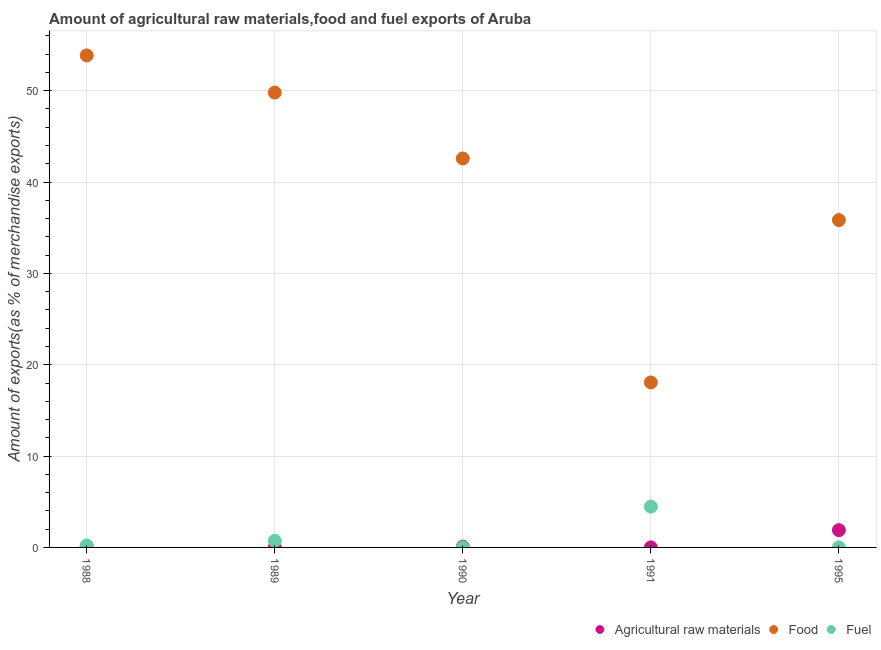What is the percentage of fuel exports in 1989?
Make the answer very short. 0.73. Across all years, what is the maximum percentage of food exports?
Your answer should be compact. 53.86. Across all years, what is the minimum percentage of food exports?
Your answer should be compact. 18.06. In which year was the percentage of raw materials exports maximum?
Offer a terse response. 1995. What is the total percentage of raw materials exports in the graph?
Provide a short and direct response. 2.08. What is the difference between the percentage of fuel exports in 1988 and that in 1989?
Keep it short and to the point. -0.51. What is the difference between the percentage of food exports in 1995 and the percentage of fuel exports in 1991?
Offer a terse response. 31.37. What is the average percentage of raw materials exports per year?
Offer a terse response. 0.42. In the year 1990, what is the difference between the percentage of raw materials exports and percentage of food exports?
Provide a short and direct response. -42.5. In how many years, is the percentage of food exports greater than 44 %?
Ensure brevity in your answer.  2. What is the ratio of the percentage of raw materials exports in 1989 to that in 1991?
Offer a terse response. 2.86. Is the difference between the percentage of fuel exports in 1989 and 1990 greater than the difference between the percentage of raw materials exports in 1989 and 1990?
Give a very brief answer. Yes. What is the difference between the highest and the second highest percentage of fuel exports?
Offer a terse response. 3.74. What is the difference between the highest and the lowest percentage of raw materials exports?
Keep it short and to the point. 1.89. Is the percentage of food exports strictly greater than the percentage of raw materials exports over the years?
Provide a succinct answer. Yes. Is the percentage of fuel exports strictly less than the percentage of raw materials exports over the years?
Keep it short and to the point. No. How many dotlines are there?
Your response must be concise. 3. Does the graph contain any zero values?
Keep it short and to the point. No. Does the graph contain grids?
Keep it short and to the point. Yes. Where does the legend appear in the graph?
Give a very brief answer. Bottom right. What is the title of the graph?
Your response must be concise. Amount of agricultural raw materials,food and fuel exports of Aruba. What is the label or title of the X-axis?
Make the answer very short. Year. What is the label or title of the Y-axis?
Offer a terse response. Amount of exports(as % of merchandise exports). What is the Amount of exports(as % of merchandise exports) in Agricultural raw materials in 1988?
Give a very brief answer. 0.09. What is the Amount of exports(as % of merchandise exports) of Food in 1988?
Your answer should be very brief. 53.86. What is the Amount of exports(as % of merchandise exports) of Fuel in 1988?
Ensure brevity in your answer.  0.21. What is the Amount of exports(as % of merchandise exports) in Agricultural raw materials in 1989?
Keep it short and to the point. 0.01. What is the Amount of exports(as % of merchandise exports) in Food in 1989?
Provide a succinct answer. 49.8. What is the Amount of exports(as % of merchandise exports) of Fuel in 1989?
Your answer should be very brief. 0.73. What is the Amount of exports(as % of merchandise exports) in Agricultural raw materials in 1990?
Give a very brief answer. 0.08. What is the Amount of exports(as % of merchandise exports) in Food in 1990?
Your response must be concise. 42.58. What is the Amount of exports(as % of merchandise exports) of Fuel in 1990?
Ensure brevity in your answer.  0. What is the Amount of exports(as % of merchandise exports) in Agricultural raw materials in 1991?
Ensure brevity in your answer.  0. What is the Amount of exports(as % of merchandise exports) in Food in 1991?
Your answer should be compact. 18.06. What is the Amount of exports(as % of merchandise exports) in Fuel in 1991?
Give a very brief answer. 4.46. What is the Amount of exports(as % of merchandise exports) in Agricultural raw materials in 1995?
Offer a terse response. 1.89. What is the Amount of exports(as % of merchandise exports) of Food in 1995?
Your response must be concise. 35.83. What is the Amount of exports(as % of merchandise exports) of Fuel in 1995?
Keep it short and to the point. 0.01. Across all years, what is the maximum Amount of exports(as % of merchandise exports) in Agricultural raw materials?
Keep it short and to the point. 1.89. Across all years, what is the maximum Amount of exports(as % of merchandise exports) of Food?
Your response must be concise. 53.86. Across all years, what is the maximum Amount of exports(as % of merchandise exports) in Fuel?
Keep it short and to the point. 4.46. Across all years, what is the minimum Amount of exports(as % of merchandise exports) of Agricultural raw materials?
Ensure brevity in your answer.  0. Across all years, what is the minimum Amount of exports(as % of merchandise exports) in Food?
Give a very brief answer. 18.06. Across all years, what is the minimum Amount of exports(as % of merchandise exports) in Fuel?
Your response must be concise. 0. What is the total Amount of exports(as % of merchandise exports) of Agricultural raw materials in the graph?
Give a very brief answer. 2.08. What is the total Amount of exports(as % of merchandise exports) in Food in the graph?
Give a very brief answer. 200.14. What is the total Amount of exports(as % of merchandise exports) of Fuel in the graph?
Offer a very short reply. 5.42. What is the difference between the Amount of exports(as % of merchandise exports) in Agricultural raw materials in 1988 and that in 1989?
Make the answer very short. 0.08. What is the difference between the Amount of exports(as % of merchandise exports) in Food in 1988 and that in 1989?
Make the answer very short. 4.07. What is the difference between the Amount of exports(as % of merchandise exports) of Fuel in 1988 and that in 1989?
Your answer should be very brief. -0.51. What is the difference between the Amount of exports(as % of merchandise exports) in Agricultural raw materials in 1988 and that in 1990?
Give a very brief answer. 0.01. What is the difference between the Amount of exports(as % of merchandise exports) in Food in 1988 and that in 1990?
Make the answer very short. 11.29. What is the difference between the Amount of exports(as % of merchandise exports) in Fuel in 1988 and that in 1990?
Your response must be concise. 0.21. What is the difference between the Amount of exports(as % of merchandise exports) of Agricultural raw materials in 1988 and that in 1991?
Give a very brief answer. 0.09. What is the difference between the Amount of exports(as % of merchandise exports) in Food in 1988 and that in 1991?
Your response must be concise. 35.8. What is the difference between the Amount of exports(as % of merchandise exports) in Fuel in 1988 and that in 1991?
Offer a very short reply. -4.25. What is the difference between the Amount of exports(as % of merchandise exports) in Agricultural raw materials in 1988 and that in 1995?
Offer a very short reply. -1.8. What is the difference between the Amount of exports(as % of merchandise exports) of Food in 1988 and that in 1995?
Keep it short and to the point. 18.03. What is the difference between the Amount of exports(as % of merchandise exports) of Fuel in 1988 and that in 1995?
Provide a short and direct response. 0.2. What is the difference between the Amount of exports(as % of merchandise exports) in Agricultural raw materials in 1989 and that in 1990?
Your answer should be compact. -0.07. What is the difference between the Amount of exports(as % of merchandise exports) of Food in 1989 and that in 1990?
Give a very brief answer. 7.22. What is the difference between the Amount of exports(as % of merchandise exports) in Fuel in 1989 and that in 1990?
Offer a very short reply. 0.72. What is the difference between the Amount of exports(as % of merchandise exports) in Agricultural raw materials in 1989 and that in 1991?
Your answer should be very brief. 0.01. What is the difference between the Amount of exports(as % of merchandise exports) in Food in 1989 and that in 1991?
Provide a short and direct response. 31.73. What is the difference between the Amount of exports(as % of merchandise exports) in Fuel in 1989 and that in 1991?
Provide a succinct answer. -3.74. What is the difference between the Amount of exports(as % of merchandise exports) in Agricultural raw materials in 1989 and that in 1995?
Provide a short and direct response. -1.88. What is the difference between the Amount of exports(as % of merchandise exports) in Food in 1989 and that in 1995?
Keep it short and to the point. 13.96. What is the difference between the Amount of exports(as % of merchandise exports) of Fuel in 1989 and that in 1995?
Ensure brevity in your answer.  0.72. What is the difference between the Amount of exports(as % of merchandise exports) of Agricultural raw materials in 1990 and that in 1991?
Ensure brevity in your answer.  0.08. What is the difference between the Amount of exports(as % of merchandise exports) of Food in 1990 and that in 1991?
Offer a very short reply. 24.52. What is the difference between the Amount of exports(as % of merchandise exports) of Fuel in 1990 and that in 1991?
Provide a short and direct response. -4.46. What is the difference between the Amount of exports(as % of merchandise exports) in Agricultural raw materials in 1990 and that in 1995?
Provide a short and direct response. -1.81. What is the difference between the Amount of exports(as % of merchandise exports) in Food in 1990 and that in 1995?
Give a very brief answer. 6.74. What is the difference between the Amount of exports(as % of merchandise exports) of Fuel in 1990 and that in 1995?
Your answer should be compact. -0.01. What is the difference between the Amount of exports(as % of merchandise exports) of Agricultural raw materials in 1991 and that in 1995?
Keep it short and to the point. -1.89. What is the difference between the Amount of exports(as % of merchandise exports) in Food in 1991 and that in 1995?
Your answer should be very brief. -17.77. What is the difference between the Amount of exports(as % of merchandise exports) of Fuel in 1991 and that in 1995?
Offer a terse response. 4.46. What is the difference between the Amount of exports(as % of merchandise exports) in Agricultural raw materials in 1988 and the Amount of exports(as % of merchandise exports) in Food in 1989?
Offer a very short reply. -49.71. What is the difference between the Amount of exports(as % of merchandise exports) in Agricultural raw materials in 1988 and the Amount of exports(as % of merchandise exports) in Fuel in 1989?
Give a very brief answer. -0.64. What is the difference between the Amount of exports(as % of merchandise exports) of Food in 1988 and the Amount of exports(as % of merchandise exports) of Fuel in 1989?
Your response must be concise. 53.14. What is the difference between the Amount of exports(as % of merchandise exports) of Agricultural raw materials in 1988 and the Amount of exports(as % of merchandise exports) of Food in 1990?
Your answer should be very brief. -42.49. What is the difference between the Amount of exports(as % of merchandise exports) in Agricultural raw materials in 1988 and the Amount of exports(as % of merchandise exports) in Fuel in 1990?
Your answer should be compact. 0.09. What is the difference between the Amount of exports(as % of merchandise exports) in Food in 1988 and the Amount of exports(as % of merchandise exports) in Fuel in 1990?
Provide a succinct answer. 53.86. What is the difference between the Amount of exports(as % of merchandise exports) in Agricultural raw materials in 1988 and the Amount of exports(as % of merchandise exports) in Food in 1991?
Your response must be concise. -17.97. What is the difference between the Amount of exports(as % of merchandise exports) of Agricultural raw materials in 1988 and the Amount of exports(as % of merchandise exports) of Fuel in 1991?
Offer a terse response. -4.38. What is the difference between the Amount of exports(as % of merchandise exports) in Food in 1988 and the Amount of exports(as % of merchandise exports) in Fuel in 1991?
Give a very brief answer. 49.4. What is the difference between the Amount of exports(as % of merchandise exports) of Agricultural raw materials in 1988 and the Amount of exports(as % of merchandise exports) of Food in 1995?
Give a very brief answer. -35.74. What is the difference between the Amount of exports(as % of merchandise exports) of Agricultural raw materials in 1988 and the Amount of exports(as % of merchandise exports) of Fuel in 1995?
Your answer should be very brief. 0.08. What is the difference between the Amount of exports(as % of merchandise exports) of Food in 1988 and the Amount of exports(as % of merchandise exports) of Fuel in 1995?
Give a very brief answer. 53.85. What is the difference between the Amount of exports(as % of merchandise exports) in Agricultural raw materials in 1989 and the Amount of exports(as % of merchandise exports) in Food in 1990?
Offer a terse response. -42.57. What is the difference between the Amount of exports(as % of merchandise exports) in Agricultural raw materials in 1989 and the Amount of exports(as % of merchandise exports) in Fuel in 1990?
Keep it short and to the point. 0.01. What is the difference between the Amount of exports(as % of merchandise exports) of Food in 1989 and the Amount of exports(as % of merchandise exports) of Fuel in 1990?
Keep it short and to the point. 49.79. What is the difference between the Amount of exports(as % of merchandise exports) in Agricultural raw materials in 1989 and the Amount of exports(as % of merchandise exports) in Food in 1991?
Give a very brief answer. -18.05. What is the difference between the Amount of exports(as % of merchandise exports) in Agricultural raw materials in 1989 and the Amount of exports(as % of merchandise exports) in Fuel in 1991?
Your answer should be compact. -4.45. What is the difference between the Amount of exports(as % of merchandise exports) of Food in 1989 and the Amount of exports(as % of merchandise exports) of Fuel in 1991?
Your answer should be compact. 45.33. What is the difference between the Amount of exports(as % of merchandise exports) in Agricultural raw materials in 1989 and the Amount of exports(as % of merchandise exports) in Food in 1995?
Offer a very short reply. -35.82. What is the difference between the Amount of exports(as % of merchandise exports) in Agricultural raw materials in 1989 and the Amount of exports(as % of merchandise exports) in Fuel in 1995?
Make the answer very short. 0. What is the difference between the Amount of exports(as % of merchandise exports) of Food in 1989 and the Amount of exports(as % of merchandise exports) of Fuel in 1995?
Your response must be concise. 49.79. What is the difference between the Amount of exports(as % of merchandise exports) in Agricultural raw materials in 1990 and the Amount of exports(as % of merchandise exports) in Food in 1991?
Make the answer very short. -17.98. What is the difference between the Amount of exports(as % of merchandise exports) in Agricultural raw materials in 1990 and the Amount of exports(as % of merchandise exports) in Fuel in 1991?
Provide a succinct answer. -4.38. What is the difference between the Amount of exports(as % of merchandise exports) of Food in 1990 and the Amount of exports(as % of merchandise exports) of Fuel in 1991?
Keep it short and to the point. 38.11. What is the difference between the Amount of exports(as % of merchandise exports) of Agricultural raw materials in 1990 and the Amount of exports(as % of merchandise exports) of Food in 1995?
Offer a terse response. -35.75. What is the difference between the Amount of exports(as % of merchandise exports) of Agricultural raw materials in 1990 and the Amount of exports(as % of merchandise exports) of Fuel in 1995?
Provide a succinct answer. 0.07. What is the difference between the Amount of exports(as % of merchandise exports) in Food in 1990 and the Amount of exports(as % of merchandise exports) in Fuel in 1995?
Offer a very short reply. 42.57. What is the difference between the Amount of exports(as % of merchandise exports) of Agricultural raw materials in 1991 and the Amount of exports(as % of merchandise exports) of Food in 1995?
Ensure brevity in your answer.  -35.83. What is the difference between the Amount of exports(as % of merchandise exports) of Agricultural raw materials in 1991 and the Amount of exports(as % of merchandise exports) of Fuel in 1995?
Provide a succinct answer. -0.01. What is the difference between the Amount of exports(as % of merchandise exports) in Food in 1991 and the Amount of exports(as % of merchandise exports) in Fuel in 1995?
Provide a short and direct response. 18.05. What is the average Amount of exports(as % of merchandise exports) in Agricultural raw materials per year?
Your response must be concise. 0.42. What is the average Amount of exports(as % of merchandise exports) in Food per year?
Your answer should be compact. 40.03. What is the average Amount of exports(as % of merchandise exports) in Fuel per year?
Make the answer very short. 1.08. In the year 1988, what is the difference between the Amount of exports(as % of merchandise exports) in Agricultural raw materials and Amount of exports(as % of merchandise exports) in Food?
Your answer should be very brief. -53.77. In the year 1988, what is the difference between the Amount of exports(as % of merchandise exports) in Agricultural raw materials and Amount of exports(as % of merchandise exports) in Fuel?
Your answer should be very brief. -0.12. In the year 1988, what is the difference between the Amount of exports(as % of merchandise exports) in Food and Amount of exports(as % of merchandise exports) in Fuel?
Your answer should be very brief. 53.65. In the year 1989, what is the difference between the Amount of exports(as % of merchandise exports) of Agricultural raw materials and Amount of exports(as % of merchandise exports) of Food?
Ensure brevity in your answer.  -49.78. In the year 1989, what is the difference between the Amount of exports(as % of merchandise exports) of Agricultural raw materials and Amount of exports(as % of merchandise exports) of Fuel?
Give a very brief answer. -0.71. In the year 1989, what is the difference between the Amount of exports(as % of merchandise exports) of Food and Amount of exports(as % of merchandise exports) of Fuel?
Provide a succinct answer. 49.07. In the year 1990, what is the difference between the Amount of exports(as % of merchandise exports) of Agricultural raw materials and Amount of exports(as % of merchandise exports) of Food?
Offer a very short reply. -42.5. In the year 1990, what is the difference between the Amount of exports(as % of merchandise exports) in Agricultural raw materials and Amount of exports(as % of merchandise exports) in Fuel?
Your answer should be very brief. 0.08. In the year 1990, what is the difference between the Amount of exports(as % of merchandise exports) in Food and Amount of exports(as % of merchandise exports) in Fuel?
Offer a terse response. 42.58. In the year 1991, what is the difference between the Amount of exports(as % of merchandise exports) in Agricultural raw materials and Amount of exports(as % of merchandise exports) in Food?
Make the answer very short. -18.06. In the year 1991, what is the difference between the Amount of exports(as % of merchandise exports) of Agricultural raw materials and Amount of exports(as % of merchandise exports) of Fuel?
Ensure brevity in your answer.  -4.46. In the year 1991, what is the difference between the Amount of exports(as % of merchandise exports) of Food and Amount of exports(as % of merchandise exports) of Fuel?
Make the answer very short. 13.6. In the year 1995, what is the difference between the Amount of exports(as % of merchandise exports) of Agricultural raw materials and Amount of exports(as % of merchandise exports) of Food?
Provide a short and direct response. -33.94. In the year 1995, what is the difference between the Amount of exports(as % of merchandise exports) in Agricultural raw materials and Amount of exports(as % of merchandise exports) in Fuel?
Your response must be concise. 1.88. In the year 1995, what is the difference between the Amount of exports(as % of merchandise exports) of Food and Amount of exports(as % of merchandise exports) of Fuel?
Your answer should be compact. 35.83. What is the ratio of the Amount of exports(as % of merchandise exports) of Agricultural raw materials in 1988 to that in 1989?
Offer a terse response. 7.29. What is the ratio of the Amount of exports(as % of merchandise exports) in Food in 1988 to that in 1989?
Ensure brevity in your answer.  1.08. What is the ratio of the Amount of exports(as % of merchandise exports) in Fuel in 1988 to that in 1989?
Offer a terse response. 0.29. What is the ratio of the Amount of exports(as % of merchandise exports) in Agricultural raw materials in 1988 to that in 1990?
Provide a short and direct response. 1.1. What is the ratio of the Amount of exports(as % of merchandise exports) of Food in 1988 to that in 1990?
Provide a short and direct response. 1.26. What is the ratio of the Amount of exports(as % of merchandise exports) in Fuel in 1988 to that in 1990?
Your response must be concise. 54.08. What is the ratio of the Amount of exports(as % of merchandise exports) in Agricultural raw materials in 1988 to that in 1991?
Your answer should be very brief. 20.86. What is the ratio of the Amount of exports(as % of merchandise exports) in Food in 1988 to that in 1991?
Your response must be concise. 2.98. What is the ratio of the Amount of exports(as % of merchandise exports) of Fuel in 1988 to that in 1991?
Your answer should be compact. 0.05. What is the ratio of the Amount of exports(as % of merchandise exports) of Agricultural raw materials in 1988 to that in 1995?
Provide a short and direct response. 0.05. What is the ratio of the Amount of exports(as % of merchandise exports) in Food in 1988 to that in 1995?
Your answer should be compact. 1.5. What is the ratio of the Amount of exports(as % of merchandise exports) of Fuel in 1988 to that in 1995?
Offer a very short reply. 22.91. What is the ratio of the Amount of exports(as % of merchandise exports) of Agricultural raw materials in 1989 to that in 1990?
Your answer should be compact. 0.15. What is the ratio of the Amount of exports(as % of merchandise exports) of Food in 1989 to that in 1990?
Provide a succinct answer. 1.17. What is the ratio of the Amount of exports(as % of merchandise exports) in Fuel in 1989 to that in 1990?
Ensure brevity in your answer.  183.9. What is the ratio of the Amount of exports(as % of merchandise exports) of Agricultural raw materials in 1989 to that in 1991?
Provide a succinct answer. 2.86. What is the ratio of the Amount of exports(as % of merchandise exports) of Food in 1989 to that in 1991?
Your response must be concise. 2.76. What is the ratio of the Amount of exports(as % of merchandise exports) of Fuel in 1989 to that in 1991?
Provide a short and direct response. 0.16. What is the ratio of the Amount of exports(as % of merchandise exports) in Agricultural raw materials in 1989 to that in 1995?
Give a very brief answer. 0.01. What is the ratio of the Amount of exports(as % of merchandise exports) in Food in 1989 to that in 1995?
Make the answer very short. 1.39. What is the ratio of the Amount of exports(as % of merchandise exports) in Fuel in 1989 to that in 1995?
Make the answer very short. 77.89. What is the ratio of the Amount of exports(as % of merchandise exports) in Agricultural raw materials in 1990 to that in 1991?
Make the answer very short. 18.9. What is the ratio of the Amount of exports(as % of merchandise exports) in Food in 1990 to that in 1991?
Ensure brevity in your answer.  2.36. What is the ratio of the Amount of exports(as % of merchandise exports) of Fuel in 1990 to that in 1991?
Provide a short and direct response. 0. What is the ratio of the Amount of exports(as % of merchandise exports) in Agricultural raw materials in 1990 to that in 1995?
Provide a short and direct response. 0.04. What is the ratio of the Amount of exports(as % of merchandise exports) in Food in 1990 to that in 1995?
Provide a short and direct response. 1.19. What is the ratio of the Amount of exports(as % of merchandise exports) in Fuel in 1990 to that in 1995?
Keep it short and to the point. 0.42. What is the ratio of the Amount of exports(as % of merchandise exports) in Agricultural raw materials in 1991 to that in 1995?
Offer a terse response. 0. What is the ratio of the Amount of exports(as % of merchandise exports) in Food in 1991 to that in 1995?
Keep it short and to the point. 0.5. What is the ratio of the Amount of exports(as % of merchandise exports) of Fuel in 1991 to that in 1995?
Make the answer very short. 479.11. What is the difference between the highest and the second highest Amount of exports(as % of merchandise exports) of Agricultural raw materials?
Provide a succinct answer. 1.8. What is the difference between the highest and the second highest Amount of exports(as % of merchandise exports) in Food?
Ensure brevity in your answer.  4.07. What is the difference between the highest and the second highest Amount of exports(as % of merchandise exports) of Fuel?
Offer a terse response. 3.74. What is the difference between the highest and the lowest Amount of exports(as % of merchandise exports) in Agricultural raw materials?
Make the answer very short. 1.89. What is the difference between the highest and the lowest Amount of exports(as % of merchandise exports) of Food?
Ensure brevity in your answer.  35.8. What is the difference between the highest and the lowest Amount of exports(as % of merchandise exports) of Fuel?
Offer a very short reply. 4.46. 